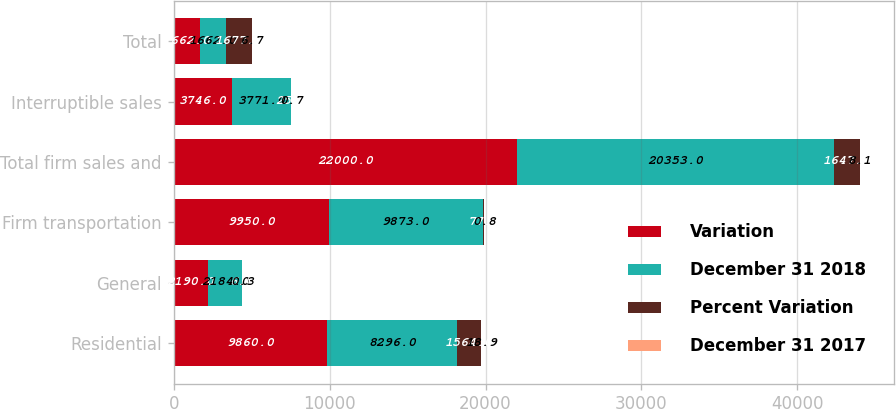Convert chart. <chart><loc_0><loc_0><loc_500><loc_500><stacked_bar_chart><ecel><fcel>Residential<fcel>General<fcel>Firm transportation<fcel>Total firm sales and<fcel>Interruptible sales<fcel>Total<nl><fcel>Variation<fcel>9860<fcel>2190<fcel>9950<fcel>22000<fcel>3746<fcel>1662<nl><fcel>December 31 2018<fcel>8296<fcel>2184<fcel>9873<fcel>20353<fcel>3771<fcel>1662<nl><fcel>Percent Variation<fcel>1564<fcel>6<fcel>77<fcel>1647<fcel>25<fcel>1677<nl><fcel>December 31 2017<fcel>18.9<fcel>0.3<fcel>0.8<fcel>8.1<fcel>0.7<fcel>6.7<nl></chart> 